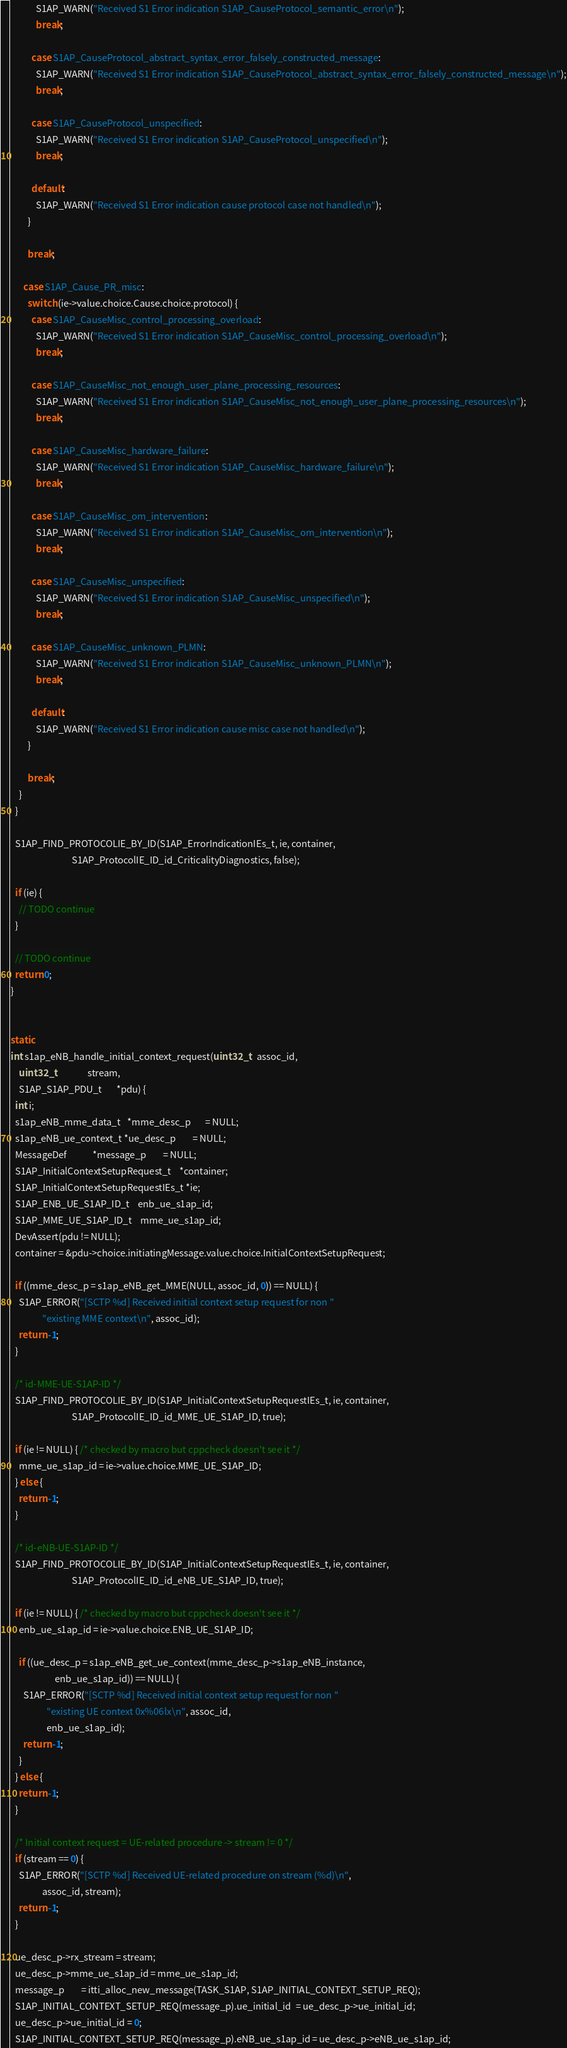<code> <loc_0><loc_0><loc_500><loc_500><_C_>            S1AP_WARN("Received S1 Error indication S1AP_CauseProtocol_semantic_error\n");
            break;

          case S1AP_CauseProtocol_abstract_syntax_error_falsely_constructed_message:
            S1AP_WARN("Received S1 Error indication S1AP_CauseProtocol_abstract_syntax_error_falsely_constructed_message\n");
            break;

          case S1AP_CauseProtocol_unspecified:
            S1AP_WARN("Received S1 Error indication S1AP_CauseProtocol_unspecified\n");
            break;

          default:
            S1AP_WARN("Received S1 Error indication cause protocol case not handled\n");
        }

        break;

      case S1AP_Cause_PR_misc:
        switch (ie->value.choice.Cause.choice.protocol) {
          case S1AP_CauseMisc_control_processing_overload:
            S1AP_WARN("Received S1 Error indication S1AP_CauseMisc_control_processing_overload\n");
            break;

          case S1AP_CauseMisc_not_enough_user_plane_processing_resources:
            S1AP_WARN("Received S1 Error indication S1AP_CauseMisc_not_enough_user_plane_processing_resources\n");
            break;

          case S1AP_CauseMisc_hardware_failure:
            S1AP_WARN("Received S1 Error indication S1AP_CauseMisc_hardware_failure\n");
            break;

          case S1AP_CauseMisc_om_intervention:
            S1AP_WARN("Received S1 Error indication S1AP_CauseMisc_om_intervention\n");
            break;

          case S1AP_CauseMisc_unspecified:
            S1AP_WARN("Received S1 Error indication S1AP_CauseMisc_unspecified\n");
            break;

          case S1AP_CauseMisc_unknown_PLMN:
            S1AP_WARN("Received S1 Error indication S1AP_CauseMisc_unknown_PLMN\n");
            break;

          default:
            S1AP_WARN("Received S1 Error indication cause misc case not handled\n");
        }

        break;
    }
  }

  S1AP_FIND_PROTOCOLIE_BY_ID(S1AP_ErrorIndicationIEs_t, ie, container,
                             S1AP_ProtocolIE_ID_id_CriticalityDiagnostics, false);

  if (ie) {
    // TODO continue
  }

  // TODO continue
  return 0;
}


static
int s1ap_eNB_handle_initial_context_request(uint32_t   assoc_id,
    uint32_t               stream,
    S1AP_S1AP_PDU_t       *pdu) {
  int i;
  s1ap_eNB_mme_data_t   *mme_desc_p       = NULL;
  s1ap_eNB_ue_context_t *ue_desc_p        = NULL;
  MessageDef            *message_p        = NULL;
  S1AP_InitialContextSetupRequest_t    *container;
  S1AP_InitialContextSetupRequestIEs_t *ie;
  S1AP_ENB_UE_S1AP_ID_t    enb_ue_s1ap_id;
  S1AP_MME_UE_S1AP_ID_t    mme_ue_s1ap_id;
  DevAssert(pdu != NULL);
  container = &pdu->choice.initiatingMessage.value.choice.InitialContextSetupRequest;

  if ((mme_desc_p = s1ap_eNB_get_MME(NULL, assoc_id, 0)) == NULL) {
    S1AP_ERROR("[SCTP %d] Received initial context setup request for non "
               "existing MME context\n", assoc_id);
    return -1;
  }

  /* id-MME-UE-S1AP-ID */
  S1AP_FIND_PROTOCOLIE_BY_ID(S1AP_InitialContextSetupRequestIEs_t, ie, container,
                             S1AP_ProtocolIE_ID_id_MME_UE_S1AP_ID, true);

  if (ie != NULL) { /* checked by macro but cppcheck doesn't see it */
    mme_ue_s1ap_id = ie->value.choice.MME_UE_S1AP_ID;
  } else {
    return -1;
  }

  /* id-eNB-UE-S1AP-ID */
  S1AP_FIND_PROTOCOLIE_BY_ID(S1AP_InitialContextSetupRequestIEs_t, ie, container,
                             S1AP_ProtocolIE_ID_id_eNB_UE_S1AP_ID, true);

  if (ie != NULL) { /* checked by macro but cppcheck doesn't see it */
    enb_ue_s1ap_id = ie->value.choice.ENB_UE_S1AP_ID;

    if ((ue_desc_p = s1ap_eNB_get_ue_context(mme_desc_p->s1ap_eNB_instance,
                     enb_ue_s1ap_id)) == NULL) {
      S1AP_ERROR("[SCTP %d] Received initial context setup request for non "
                 "existing UE context 0x%06lx\n", assoc_id,
                 enb_ue_s1ap_id);
      return -1;
    }
  } else {
    return -1;
  }

  /* Initial context request = UE-related procedure -> stream != 0 */
  if (stream == 0) {
    S1AP_ERROR("[SCTP %d] Received UE-related procedure on stream (%d)\n",
               assoc_id, stream);
    return -1;
  }

  ue_desc_p->rx_stream = stream;
  ue_desc_p->mme_ue_s1ap_id = mme_ue_s1ap_id;
  message_p        = itti_alloc_new_message(TASK_S1AP, S1AP_INITIAL_CONTEXT_SETUP_REQ);
  S1AP_INITIAL_CONTEXT_SETUP_REQ(message_p).ue_initial_id  = ue_desc_p->ue_initial_id;
  ue_desc_p->ue_initial_id = 0;
  S1AP_INITIAL_CONTEXT_SETUP_REQ(message_p).eNB_ue_s1ap_id = ue_desc_p->eNB_ue_s1ap_id;</code> 